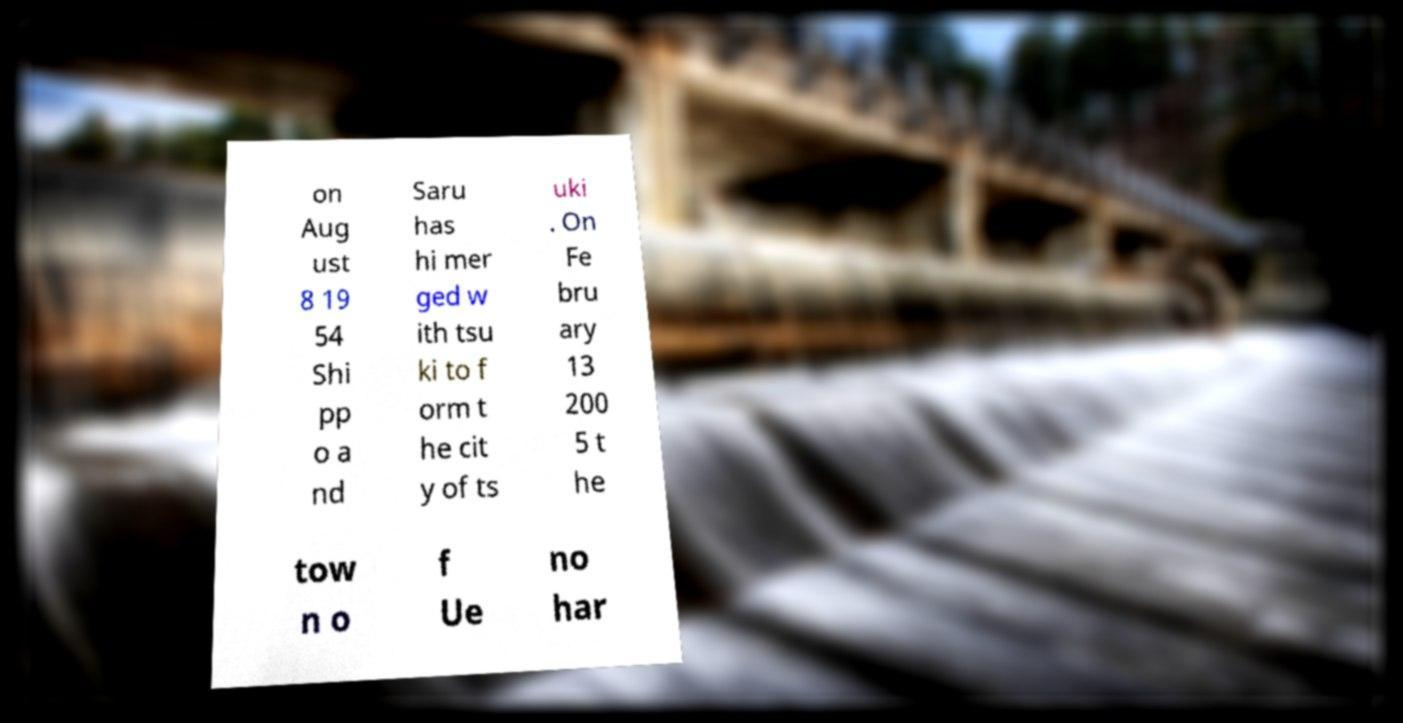Please read and relay the text visible in this image. What does it say? on Aug ust 8 19 54 Shi pp o a nd Saru has hi mer ged w ith tsu ki to f orm t he cit y of ts uki . On Fe bru ary 13 200 5 t he tow n o f Ue no har 